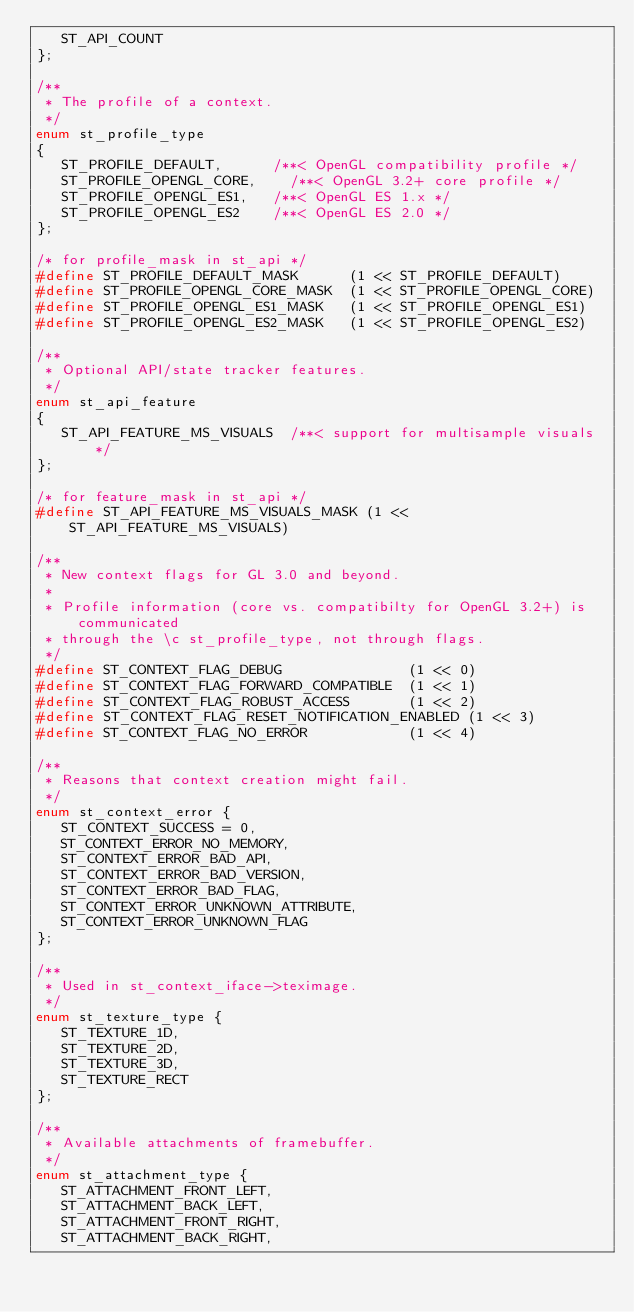<code> <loc_0><loc_0><loc_500><loc_500><_C_>   ST_API_COUNT
};

/**
 * The profile of a context.
 */
enum st_profile_type
{
   ST_PROFILE_DEFAULT,			/**< OpenGL compatibility profile */
   ST_PROFILE_OPENGL_CORE,		/**< OpenGL 3.2+ core profile */
   ST_PROFILE_OPENGL_ES1,		/**< OpenGL ES 1.x */
   ST_PROFILE_OPENGL_ES2		/**< OpenGL ES 2.0 */
};

/* for profile_mask in st_api */
#define ST_PROFILE_DEFAULT_MASK      (1 << ST_PROFILE_DEFAULT)
#define ST_PROFILE_OPENGL_CORE_MASK  (1 << ST_PROFILE_OPENGL_CORE)
#define ST_PROFILE_OPENGL_ES1_MASK   (1 << ST_PROFILE_OPENGL_ES1)
#define ST_PROFILE_OPENGL_ES2_MASK   (1 << ST_PROFILE_OPENGL_ES2)

/**
 * Optional API/state tracker features.
 */
enum st_api_feature
{
   ST_API_FEATURE_MS_VISUALS  /**< support for multisample visuals */
};

/* for feature_mask in st_api */
#define ST_API_FEATURE_MS_VISUALS_MASK (1 << ST_API_FEATURE_MS_VISUALS)

/**
 * New context flags for GL 3.0 and beyond.
 *
 * Profile information (core vs. compatibilty for OpenGL 3.2+) is communicated
 * through the \c st_profile_type, not through flags.
 */
#define ST_CONTEXT_FLAG_DEBUG               (1 << 0)
#define ST_CONTEXT_FLAG_FORWARD_COMPATIBLE  (1 << 1)
#define ST_CONTEXT_FLAG_ROBUST_ACCESS       (1 << 2)
#define ST_CONTEXT_FLAG_RESET_NOTIFICATION_ENABLED (1 << 3)
#define ST_CONTEXT_FLAG_NO_ERROR            (1 << 4)

/**
 * Reasons that context creation might fail.
 */
enum st_context_error {
   ST_CONTEXT_SUCCESS = 0,
   ST_CONTEXT_ERROR_NO_MEMORY,
   ST_CONTEXT_ERROR_BAD_API,
   ST_CONTEXT_ERROR_BAD_VERSION,
   ST_CONTEXT_ERROR_BAD_FLAG,
   ST_CONTEXT_ERROR_UNKNOWN_ATTRIBUTE,
   ST_CONTEXT_ERROR_UNKNOWN_FLAG
};

/**
 * Used in st_context_iface->teximage.
 */
enum st_texture_type {
   ST_TEXTURE_1D,
   ST_TEXTURE_2D,
   ST_TEXTURE_3D,
   ST_TEXTURE_RECT
};

/**
 * Available attachments of framebuffer.
 */
enum st_attachment_type {
   ST_ATTACHMENT_FRONT_LEFT,
   ST_ATTACHMENT_BACK_LEFT,
   ST_ATTACHMENT_FRONT_RIGHT,
   ST_ATTACHMENT_BACK_RIGHT,</code> 